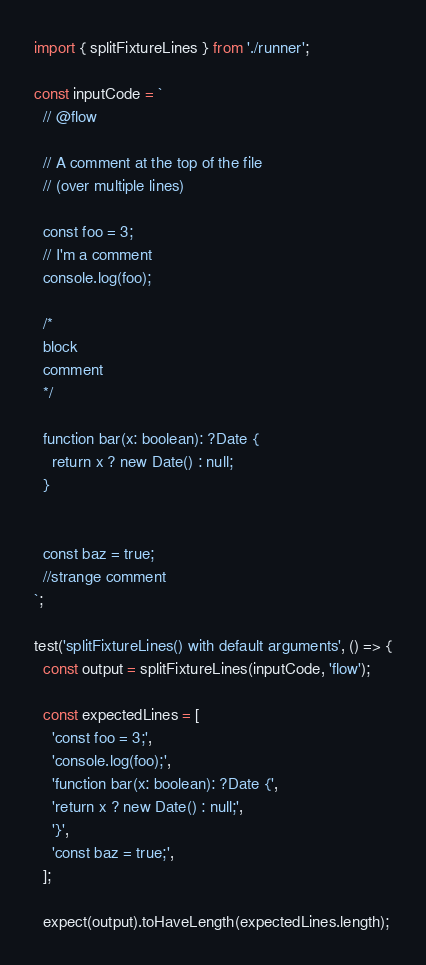Convert code to text. <code><loc_0><loc_0><loc_500><loc_500><_TypeScript_>import { splitFixtureLines } from './runner';

const inputCode = `
  // @flow

  // A comment at the top of the file
  // (over multiple lines)

  const foo = 3;
  // I'm a comment
  console.log(foo);

  /*
  block
  comment
  */

  function bar(x: boolean): ?Date {
    return x ? new Date() : null;
  }


  const baz = true;
  //strange comment
`;

test('splitFixtureLines() with default arguments', () => {
  const output = splitFixtureLines(inputCode, 'flow');

  const expectedLines = [
    'const foo = 3;',
    'console.log(foo);',
    'function bar(x: boolean): ?Date {',
    'return x ? new Date() : null;',
    '}',
    'const baz = true;',
  ];

  expect(output).toHaveLength(expectedLines.length);</code> 